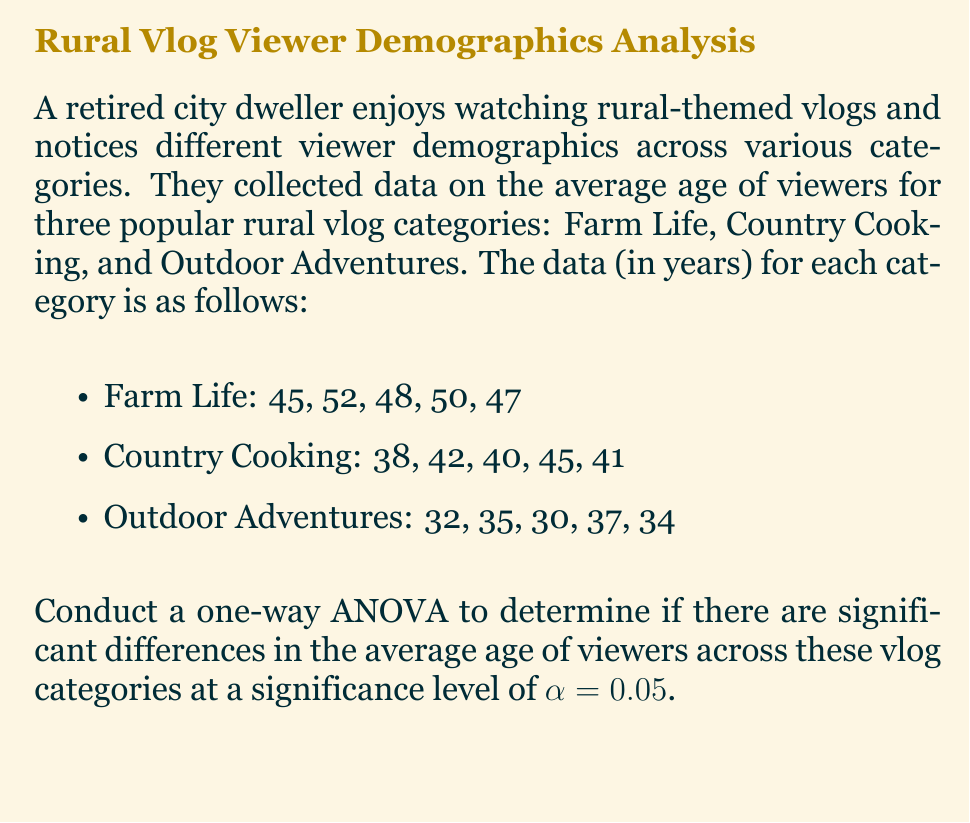Provide a solution to this math problem. To conduct a one-way ANOVA, we'll follow these steps:

1. Calculate the sum of squares total (SST), sum of squares between (SSB), and sum of squares within (SSW).
2. Calculate the degrees of freedom (df) for between groups and within groups.
3. Calculate the mean square between (MSB) and mean square within (MSW).
4. Calculate the F-statistic.
5. Compare the F-statistic to the critical F-value.

Step 1: Calculate SST, SSB, and SSW

First, we need to calculate the grand mean:
$$\bar{X} = \frac{45+52+48+50+47+38+42+40+45+41+32+35+30+37+34}{15} = 41.07$$

Now, we can calculate SST:
$$SST = \sum_{i=1}^{n} (X_i - \bar{X})^2 = 866.93$$

For SSB, we need the group means:
Farm Life: $\bar{X_1} = 48.4$
Country Cooking: $\bar{X_2} = 41.2$
Outdoor Adventures: $\bar{X_3} = 33.6$

$$SSB = n_1(\bar{X_1} - \bar{X})^2 + n_2(\bar{X_2} - \bar{X})^2 + n_3(\bar{X_3} - \bar{X})^2$$
$$SSB = 5(48.4 - 41.07)^2 + 5(41.2 - 41.07)^2 + 5(33.6 - 41.07)^2 = 680.13$$

$$SSW = SST - SSB = 866.93 - 680.13 = 186.8$$

Step 2: Calculate degrees of freedom

df between = k - 1 = 3 - 1 = 2 (where k is the number of groups)
df within = N - k = 15 - 3 = 12 (where N is the total number of observations)

Step 3: Calculate MSB and MSW

$$MSB = \frac{SSB}{df_{between}} = \frac{680.13}{2} = 340.065$$
$$MSW = \frac{SSW}{df_{within}} = \frac{186.8}{12} = 15.57$$

Step 4: Calculate F-statistic

$$F = \frac{MSB}{MSW} = \frac{340.065}{15.57} = 21.84$$

Step 5: Compare F-statistic to critical F-value

The critical F-value for $\alpha = 0.05$, df between = 2, and df within = 12 is approximately 3.89.

Since our calculated F-statistic (21.84) is greater than the critical F-value (3.89), we reject the null hypothesis.
Answer: $F(2,12) = 21.84, p < 0.05$. Significant differences exist in viewer age across vlog categories. 